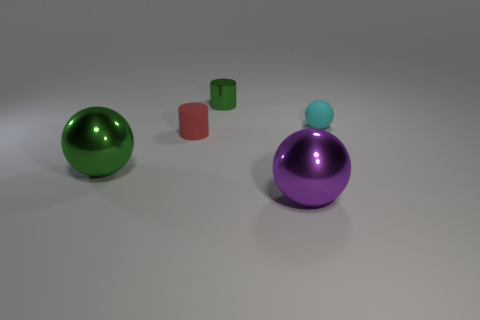Is the number of purple balls behind the matte sphere greater than the number of tiny cylinders in front of the tiny red cylinder?
Make the answer very short. No. What number of other things are there of the same size as the matte cylinder?
Your answer should be very brief. 2. There is a ball that is both to the right of the red object and in front of the rubber cylinder; what is its material?
Offer a terse response. Metal. What material is the large green object that is the same shape as the tiny cyan matte thing?
Your answer should be very brief. Metal. How many small rubber balls are in front of the large thing that is behind the big sphere right of the large green thing?
Keep it short and to the point. 0. Is there anything else that has the same color as the rubber cylinder?
Provide a short and direct response. No. How many things are behind the tiny red thing and right of the small green shiny object?
Ensure brevity in your answer.  1. There is a ball that is on the right side of the purple metal object; is it the same size as the thing behind the cyan rubber sphere?
Your answer should be compact. Yes. What number of things are big metal spheres that are on the left side of the green cylinder or small green things?
Your answer should be very brief. 2. What is the small thing that is behind the small cyan rubber thing made of?
Keep it short and to the point. Metal. 